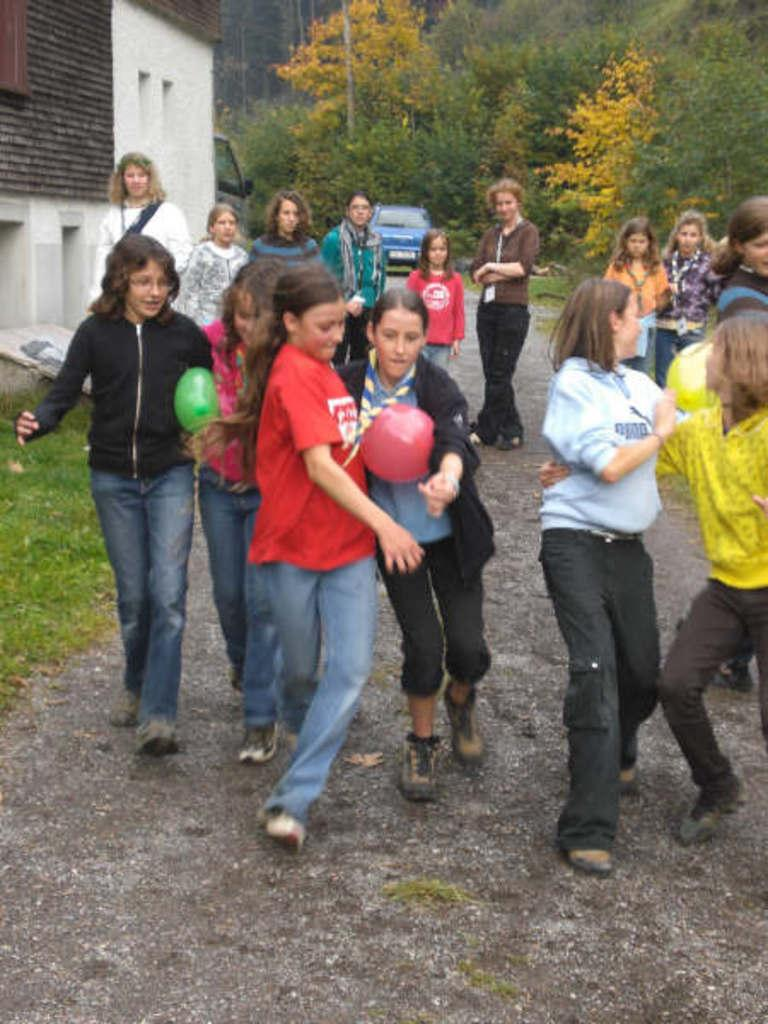What are the girls in the image doing? The girls in the image are playing a game. What is the game involving? The game involves balloons. Where is the game being played? The game is being played on a walkway. What can be seen in the background of the image? There are people, a house, grass, plants, a vehicle, and trees visible in the background of the image. What type of twig is being used as a statement in the game? There is no twig or statement present in the game being played in the image. 